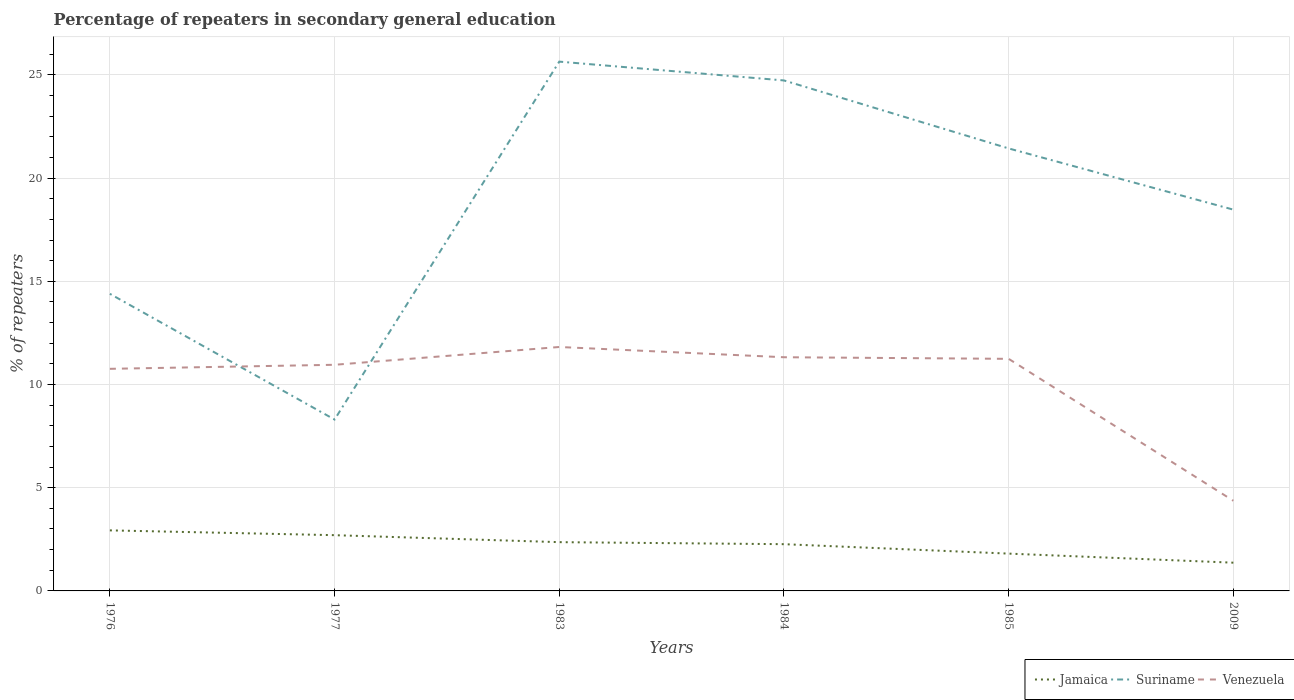How many different coloured lines are there?
Keep it short and to the point. 3. Does the line corresponding to Venezuela intersect with the line corresponding to Jamaica?
Offer a very short reply. No. Across all years, what is the maximum percentage of repeaters in secondary general education in Jamaica?
Offer a very short reply. 1.37. In which year was the percentage of repeaters in secondary general education in Jamaica maximum?
Your answer should be compact. 2009. What is the total percentage of repeaters in secondary general education in Jamaica in the graph?
Make the answer very short. 0.55. What is the difference between the highest and the second highest percentage of repeaters in secondary general education in Suriname?
Provide a succinct answer. 17.34. What is the difference between the highest and the lowest percentage of repeaters in secondary general education in Venezuela?
Your answer should be very brief. 5. How many lines are there?
Offer a very short reply. 3. How many years are there in the graph?
Your response must be concise. 6. Where does the legend appear in the graph?
Your response must be concise. Bottom right. How many legend labels are there?
Offer a terse response. 3. How are the legend labels stacked?
Your answer should be very brief. Horizontal. What is the title of the graph?
Your response must be concise. Percentage of repeaters in secondary general education. What is the label or title of the Y-axis?
Give a very brief answer. % of repeaters. What is the % of repeaters of Jamaica in 1976?
Provide a short and direct response. 2.93. What is the % of repeaters in Suriname in 1976?
Provide a short and direct response. 14.39. What is the % of repeaters in Venezuela in 1976?
Keep it short and to the point. 10.76. What is the % of repeaters in Jamaica in 1977?
Keep it short and to the point. 2.7. What is the % of repeaters in Suriname in 1977?
Provide a short and direct response. 8.3. What is the % of repeaters of Venezuela in 1977?
Keep it short and to the point. 10.96. What is the % of repeaters of Jamaica in 1983?
Give a very brief answer. 2.36. What is the % of repeaters in Suriname in 1983?
Offer a terse response. 25.64. What is the % of repeaters of Venezuela in 1983?
Your response must be concise. 11.82. What is the % of repeaters of Jamaica in 1984?
Make the answer very short. 2.26. What is the % of repeaters in Suriname in 1984?
Provide a short and direct response. 24.73. What is the % of repeaters of Venezuela in 1984?
Your response must be concise. 11.32. What is the % of repeaters in Jamaica in 1985?
Provide a short and direct response. 1.81. What is the % of repeaters in Suriname in 1985?
Your response must be concise. 21.44. What is the % of repeaters of Venezuela in 1985?
Keep it short and to the point. 11.24. What is the % of repeaters in Jamaica in 2009?
Ensure brevity in your answer.  1.37. What is the % of repeaters in Suriname in 2009?
Make the answer very short. 18.47. What is the % of repeaters in Venezuela in 2009?
Offer a very short reply. 4.37. Across all years, what is the maximum % of repeaters in Jamaica?
Keep it short and to the point. 2.93. Across all years, what is the maximum % of repeaters in Suriname?
Your answer should be compact. 25.64. Across all years, what is the maximum % of repeaters of Venezuela?
Offer a terse response. 11.82. Across all years, what is the minimum % of repeaters of Jamaica?
Keep it short and to the point. 1.37. Across all years, what is the minimum % of repeaters of Suriname?
Provide a succinct answer. 8.3. Across all years, what is the minimum % of repeaters in Venezuela?
Your answer should be very brief. 4.37. What is the total % of repeaters in Jamaica in the graph?
Offer a terse response. 13.44. What is the total % of repeaters of Suriname in the graph?
Ensure brevity in your answer.  112.98. What is the total % of repeaters of Venezuela in the graph?
Offer a very short reply. 60.47. What is the difference between the % of repeaters in Jamaica in 1976 and that in 1977?
Make the answer very short. 0.23. What is the difference between the % of repeaters of Suriname in 1976 and that in 1977?
Provide a succinct answer. 6.09. What is the difference between the % of repeaters of Venezuela in 1976 and that in 1977?
Provide a short and direct response. -0.2. What is the difference between the % of repeaters in Jamaica in 1976 and that in 1983?
Offer a terse response. 0.57. What is the difference between the % of repeaters of Suriname in 1976 and that in 1983?
Ensure brevity in your answer.  -11.25. What is the difference between the % of repeaters in Venezuela in 1976 and that in 1983?
Your answer should be very brief. -1.06. What is the difference between the % of repeaters in Jamaica in 1976 and that in 1984?
Keep it short and to the point. 0.67. What is the difference between the % of repeaters in Suriname in 1976 and that in 1984?
Your response must be concise. -10.34. What is the difference between the % of repeaters in Venezuela in 1976 and that in 1984?
Make the answer very short. -0.56. What is the difference between the % of repeaters in Jamaica in 1976 and that in 1985?
Keep it short and to the point. 1.13. What is the difference between the % of repeaters of Suriname in 1976 and that in 1985?
Offer a very short reply. -7.04. What is the difference between the % of repeaters of Venezuela in 1976 and that in 1985?
Make the answer very short. -0.48. What is the difference between the % of repeaters in Jamaica in 1976 and that in 2009?
Keep it short and to the point. 1.56. What is the difference between the % of repeaters in Suriname in 1976 and that in 2009?
Make the answer very short. -4.08. What is the difference between the % of repeaters of Venezuela in 1976 and that in 2009?
Your response must be concise. 6.39. What is the difference between the % of repeaters of Jamaica in 1977 and that in 1983?
Make the answer very short. 0.34. What is the difference between the % of repeaters of Suriname in 1977 and that in 1983?
Make the answer very short. -17.34. What is the difference between the % of repeaters in Venezuela in 1977 and that in 1983?
Your answer should be compact. -0.86. What is the difference between the % of repeaters in Jamaica in 1977 and that in 1984?
Give a very brief answer. 0.44. What is the difference between the % of repeaters in Suriname in 1977 and that in 1984?
Ensure brevity in your answer.  -16.43. What is the difference between the % of repeaters of Venezuela in 1977 and that in 1984?
Provide a succinct answer. -0.37. What is the difference between the % of repeaters of Jamaica in 1977 and that in 1985?
Offer a very short reply. 0.89. What is the difference between the % of repeaters in Suriname in 1977 and that in 1985?
Provide a short and direct response. -13.14. What is the difference between the % of repeaters of Venezuela in 1977 and that in 1985?
Offer a very short reply. -0.29. What is the difference between the % of repeaters of Jamaica in 1977 and that in 2009?
Your answer should be compact. 1.33. What is the difference between the % of repeaters in Suriname in 1977 and that in 2009?
Keep it short and to the point. -10.17. What is the difference between the % of repeaters in Venezuela in 1977 and that in 2009?
Make the answer very short. 6.59. What is the difference between the % of repeaters in Jamaica in 1983 and that in 1984?
Your response must be concise. 0.1. What is the difference between the % of repeaters in Suriname in 1983 and that in 1984?
Offer a very short reply. 0.91. What is the difference between the % of repeaters of Venezuela in 1983 and that in 1984?
Keep it short and to the point. 0.5. What is the difference between the % of repeaters in Jamaica in 1983 and that in 1985?
Your response must be concise. 0.55. What is the difference between the % of repeaters in Suriname in 1983 and that in 1985?
Ensure brevity in your answer.  4.21. What is the difference between the % of repeaters of Venezuela in 1983 and that in 1985?
Offer a very short reply. 0.57. What is the difference between the % of repeaters of Jamaica in 1983 and that in 2009?
Give a very brief answer. 0.99. What is the difference between the % of repeaters in Suriname in 1983 and that in 2009?
Make the answer very short. 7.17. What is the difference between the % of repeaters of Venezuela in 1983 and that in 2009?
Keep it short and to the point. 7.45. What is the difference between the % of repeaters in Jamaica in 1984 and that in 1985?
Offer a terse response. 0.46. What is the difference between the % of repeaters of Suriname in 1984 and that in 1985?
Your answer should be compact. 3.29. What is the difference between the % of repeaters of Venezuela in 1984 and that in 1985?
Keep it short and to the point. 0.08. What is the difference between the % of repeaters in Jamaica in 1984 and that in 2009?
Provide a short and direct response. 0.9. What is the difference between the % of repeaters in Suriname in 1984 and that in 2009?
Offer a very short reply. 6.26. What is the difference between the % of repeaters in Venezuela in 1984 and that in 2009?
Your answer should be compact. 6.95. What is the difference between the % of repeaters of Jamaica in 1985 and that in 2009?
Your answer should be very brief. 0.44. What is the difference between the % of repeaters in Suriname in 1985 and that in 2009?
Offer a very short reply. 2.97. What is the difference between the % of repeaters of Venezuela in 1985 and that in 2009?
Your response must be concise. 6.88. What is the difference between the % of repeaters of Jamaica in 1976 and the % of repeaters of Suriname in 1977?
Your response must be concise. -5.37. What is the difference between the % of repeaters in Jamaica in 1976 and the % of repeaters in Venezuela in 1977?
Offer a terse response. -8.02. What is the difference between the % of repeaters of Suriname in 1976 and the % of repeaters of Venezuela in 1977?
Your answer should be very brief. 3.44. What is the difference between the % of repeaters of Jamaica in 1976 and the % of repeaters of Suriname in 1983?
Keep it short and to the point. -22.71. What is the difference between the % of repeaters in Jamaica in 1976 and the % of repeaters in Venezuela in 1983?
Your answer should be compact. -8.88. What is the difference between the % of repeaters in Suriname in 1976 and the % of repeaters in Venezuela in 1983?
Your answer should be compact. 2.58. What is the difference between the % of repeaters of Jamaica in 1976 and the % of repeaters of Suriname in 1984?
Give a very brief answer. -21.8. What is the difference between the % of repeaters in Jamaica in 1976 and the % of repeaters in Venezuela in 1984?
Make the answer very short. -8.39. What is the difference between the % of repeaters in Suriname in 1976 and the % of repeaters in Venezuela in 1984?
Offer a very short reply. 3.07. What is the difference between the % of repeaters in Jamaica in 1976 and the % of repeaters in Suriname in 1985?
Your response must be concise. -18.5. What is the difference between the % of repeaters in Jamaica in 1976 and the % of repeaters in Venezuela in 1985?
Give a very brief answer. -8.31. What is the difference between the % of repeaters of Suriname in 1976 and the % of repeaters of Venezuela in 1985?
Offer a very short reply. 3.15. What is the difference between the % of repeaters of Jamaica in 1976 and the % of repeaters of Suriname in 2009?
Offer a terse response. -15.54. What is the difference between the % of repeaters of Jamaica in 1976 and the % of repeaters of Venezuela in 2009?
Your answer should be very brief. -1.44. What is the difference between the % of repeaters of Suriname in 1976 and the % of repeaters of Venezuela in 2009?
Provide a short and direct response. 10.03. What is the difference between the % of repeaters in Jamaica in 1977 and the % of repeaters in Suriname in 1983?
Provide a succinct answer. -22.94. What is the difference between the % of repeaters in Jamaica in 1977 and the % of repeaters in Venezuela in 1983?
Offer a terse response. -9.12. What is the difference between the % of repeaters in Suriname in 1977 and the % of repeaters in Venezuela in 1983?
Keep it short and to the point. -3.52. What is the difference between the % of repeaters in Jamaica in 1977 and the % of repeaters in Suriname in 1984?
Offer a very short reply. -22.03. What is the difference between the % of repeaters in Jamaica in 1977 and the % of repeaters in Venezuela in 1984?
Give a very brief answer. -8.62. What is the difference between the % of repeaters of Suriname in 1977 and the % of repeaters of Venezuela in 1984?
Provide a succinct answer. -3.02. What is the difference between the % of repeaters of Jamaica in 1977 and the % of repeaters of Suriname in 1985?
Give a very brief answer. -18.74. What is the difference between the % of repeaters of Jamaica in 1977 and the % of repeaters of Venezuela in 1985?
Offer a terse response. -8.54. What is the difference between the % of repeaters in Suriname in 1977 and the % of repeaters in Venezuela in 1985?
Offer a very short reply. -2.94. What is the difference between the % of repeaters in Jamaica in 1977 and the % of repeaters in Suriname in 2009?
Your answer should be very brief. -15.77. What is the difference between the % of repeaters in Jamaica in 1977 and the % of repeaters in Venezuela in 2009?
Your answer should be very brief. -1.67. What is the difference between the % of repeaters in Suriname in 1977 and the % of repeaters in Venezuela in 2009?
Your response must be concise. 3.93. What is the difference between the % of repeaters of Jamaica in 1983 and the % of repeaters of Suriname in 1984?
Your response must be concise. -22.37. What is the difference between the % of repeaters in Jamaica in 1983 and the % of repeaters in Venezuela in 1984?
Your answer should be compact. -8.96. What is the difference between the % of repeaters in Suriname in 1983 and the % of repeaters in Venezuela in 1984?
Make the answer very short. 14.32. What is the difference between the % of repeaters in Jamaica in 1983 and the % of repeaters in Suriname in 1985?
Offer a very short reply. -19.08. What is the difference between the % of repeaters in Jamaica in 1983 and the % of repeaters in Venezuela in 1985?
Provide a short and direct response. -8.88. What is the difference between the % of repeaters in Suriname in 1983 and the % of repeaters in Venezuela in 1985?
Offer a terse response. 14.4. What is the difference between the % of repeaters in Jamaica in 1983 and the % of repeaters in Suriname in 2009?
Ensure brevity in your answer.  -16.11. What is the difference between the % of repeaters in Jamaica in 1983 and the % of repeaters in Venezuela in 2009?
Offer a terse response. -2.01. What is the difference between the % of repeaters in Suriname in 1983 and the % of repeaters in Venezuela in 2009?
Provide a succinct answer. 21.27. What is the difference between the % of repeaters of Jamaica in 1984 and the % of repeaters of Suriname in 1985?
Your answer should be compact. -19.17. What is the difference between the % of repeaters of Jamaica in 1984 and the % of repeaters of Venezuela in 1985?
Provide a short and direct response. -8.98. What is the difference between the % of repeaters of Suriname in 1984 and the % of repeaters of Venezuela in 1985?
Provide a succinct answer. 13.49. What is the difference between the % of repeaters in Jamaica in 1984 and the % of repeaters in Suriname in 2009?
Give a very brief answer. -16.21. What is the difference between the % of repeaters of Jamaica in 1984 and the % of repeaters of Venezuela in 2009?
Keep it short and to the point. -2.1. What is the difference between the % of repeaters of Suriname in 1984 and the % of repeaters of Venezuela in 2009?
Your answer should be very brief. 20.36. What is the difference between the % of repeaters of Jamaica in 1985 and the % of repeaters of Suriname in 2009?
Ensure brevity in your answer.  -16.66. What is the difference between the % of repeaters in Jamaica in 1985 and the % of repeaters in Venezuela in 2009?
Provide a succinct answer. -2.56. What is the difference between the % of repeaters in Suriname in 1985 and the % of repeaters in Venezuela in 2009?
Your answer should be very brief. 17.07. What is the average % of repeaters of Jamaica per year?
Give a very brief answer. 2.24. What is the average % of repeaters in Suriname per year?
Offer a terse response. 18.83. What is the average % of repeaters of Venezuela per year?
Your answer should be very brief. 10.08. In the year 1976, what is the difference between the % of repeaters in Jamaica and % of repeaters in Suriname?
Your response must be concise. -11.46. In the year 1976, what is the difference between the % of repeaters in Jamaica and % of repeaters in Venezuela?
Offer a terse response. -7.83. In the year 1976, what is the difference between the % of repeaters of Suriname and % of repeaters of Venezuela?
Give a very brief answer. 3.63. In the year 1977, what is the difference between the % of repeaters of Jamaica and % of repeaters of Suriname?
Give a very brief answer. -5.6. In the year 1977, what is the difference between the % of repeaters of Jamaica and % of repeaters of Venezuela?
Offer a very short reply. -8.26. In the year 1977, what is the difference between the % of repeaters of Suriname and % of repeaters of Venezuela?
Your response must be concise. -2.65. In the year 1983, what is the difference between the % of repeaters in Jamaica and % of repeaters in Suriname?
Your answer should be very brief. -23.28. In the year 1983, what is the difference between the % of repeaters in Jamaica and % of repeaters in Venezuela?
Provide a short and direct response. -9.46. In the year 1983, what is the difference between the % of repeaters of Suriname and % of repeaters of Venezuela?
Your response must be concise. 13.83. In the year 1984, what is the difference between the % of repeaters of Jamaica and % of repeaters of Suriname?
Offer a very short reply. -22.47. In the year 1984, what is the difference between the % of repeaters in Jamaica and % of repeaters in Venezuela?
Your answer should be compact. -9.06. In the year 1984, what is the difference between the % of repeaters in Suriname and % of repeaters in Venezuela?
Ensure brevity in your answer.  13.41. In the year 1985, what is the difference between the % of repeaters of Jamaica and % of repeaters of Suriname?
Provide a succinct answer. -19.63. In the year 1985, what is the difference between the % of repeaters of Jamaica and % of repeaters of Venezuela?
Ensure brevity in your answer.  -9.44. In the year 1985, what is the difference between the % of repeaters of Suriname and % of repeaters of Venezuela?
Offer a very short reply. 10.19. In the year 2009, what is the difference between the % of repeaters in Jamaica and % of repeaters in Suriname?
Make the answer very short. -17.1. In the year 2009, what is the difference between the % of repeaters of Jamaica and % of repeaters of Venezuela?
Your response must be concise. -3. In the year 2009, what is the difference between the % of repeaters of Suriname and % of repeaters of Venezuela?
Your response must be concise. 14.1. What is the ratio of the % of repeaters of Jamaica in 1976 to that in 1977?
Your answer should be very brief. 1.09. What is the ratio of the % of repeaters in Suriname in 1976 to that in 1977?
Your answer should be compact. 1.73. What is the ratio of the % of repeaters of Venezuela in 1976 to that in 1977?
Make the answer very short. 0.98. What is the ratio of the % of repeaters of Jamaica in 1976 to that in 1983?
Your answer should be compact. 1.24. What is the ratio of the % of repeaters of Suriname in 1976 to that in 1983?
Give a very brief answer. 0.56. What is the ratio of the % of repeaters in Venezuela in 1976 to that in 1983?
Your response must be concise. 0.91. What is the ratio of the % of repeaters in Jamaica in 1976 to that in 1984?
Ensure brevity in your answer.  1.3. What is the ratio of the % of repeaters in Suriname in 1976 to that in 1984?
Your answer should be very brief. 0.58. What is the ratio of the % of repeaters in Venezuela in 1976 to that in 1984?
Offer a very short reply. 0.95. What is the ratio of the % of repeaters of Jamaica in 1976 to that in 1985?
Provide a short and direct response. 1.62. What is the ratio of the % of repeaters of Suriname in 1976 to that in 1985?
Offer a very short reply. 0.67. What is the ratio of the % of repeaters in Venezuela in 1976 to that in 1985?
Your answer should be very brief. 0.96. What is the ratio of the % of repeaters in Jamaica in 1976 to that in 2009?
Keep it short and to the point. 2.14. What is the ratio of the % of repeaters of Suriname in 1976 to that in 2009?
Give a very brief answer. 0.78. What is the ratio of the % of repeaters of Venezuela in 1976 to that in 2009?
Ensure brevity in your answer.  2.46. What is the ratio of the % of repeaters of Jamaica in 1977 to that in 1983?
Offer a terse response. 1.14. What is the ratio of the % of repeaters in Suriname in 1977 to that in 1983?
Make the answer very short. 0.32. What is the ratio of the % of repeaters of Venezuela in 1977 to that in 1983?
Offer a very short reply. 0.93. What is the ratio of the % of repeaters of Jamaica in 1977 to that in 1984?
Your answer should be compact. 1.19. What is the ratio of the % of repeaters in Suriname in 1977 to that in 1984?
Offer a terse response. 0.34. What is the ratio of the % of repeaters of Venezuela in 1977 to that in 1984?
Make the answer very short. 0.97. What is the ratio of the % of repeaters of Jamaica in 1977 to that in 1985?
Your answer should be compact. 1.49. What is the ratio of the % of repeaters in Suriname in 1977 to that in 1985?
Your response must be concise. 0.39. What is the ratio of the % of repeaters of Venezuela in 1977 to that in 1985?
Your answer should be very brief. 0.97. What is the ratio of the % of repeaters in Jamaica in 1977 to that in 2009?
Ensure brevity in your answer.  1.97. What is the ratio of the % of repeaters of Suriname in 1977 to that in 2009?
Keep it short and to the point. 0.45. What is the ratio of the % of repeaters in Venezuela in 1977 to that in 2009?
Offer a very short reply. 2.51. What is the ratio of the % of repeaters in Jamaica in 1983 to that in 1984?
Provide a succinct answer. 1.04. What is the ratio of the % of repeaters in Suriname in 1983 to that in 1984?
Offer a very short reply. 1.04. What is the ratio of the % of repeaters in Venezuela in 1983 to that in 1984?
Your answer should be compact. 1.04. What is the ratio of the % of repeaters in Jamaica in 1983 to that in 1985?
Keep it short and to the point. 1.31. What is the ratio of the % of repeaters in Suriname in 1983 to that in 1985?
Make the answer very short. 1.2. What is the ratio of the % of repeaters of Venezuela in 1983 to that in 1985?
Offer a very short reply. 1.05. What is the ratio of the % of repeaters in Jamaica in 1983 to that in 2009?
Give a very brief answer. 1.73. What is the ratio of the % of repeaters of Suriname in 1983 to that in 2009?
Provide a short and direct response. 1.39. What is the ratio of the % of repeaters in Venezuela in 1983 to that in 2009?
Offer a very short reply. 2.71. What is the ratio of the % of repeaters in Jamaica in 1984 to that in 1985?
Provide a short and direct response. 1.25. What is the ratio of the % of repeaters of Suriname in 1984 to that in 1985?
Your answer should be compact. 1.15. What is the ratio of the % of repeaters of Jamaica in 1984 to that in 2009?
Your answer should be very brief. 1.66. What is the ratio of the % of repeaters of Suriname in 1984 to that in 2009?
Make the answer very short. 1.34. What is the ratio of the % of repeaters of Venezuela in 1984 to that in 2009?
Your answer should be compact. 2.59. What is the ratio of the % of repeaters of Jamaica in 1985 to that in 2009?
Your answer should be compact. 1.32. What is the ratio of the % of repeaters in Suriname in 1985 to that in 2009?
Your response must be concise. 1.16. What is the ratio of the % of repeaters in Venezuela in 1985 to that in 2009?
Your answer should be compact. 2.57. What is the difference between the highest and the second highest % of repeaters in Jamaica?
Your response must be concise. 0.23. What is the difference between the highest and the second highest % of repeaters in Suriname?
Provide a succinct answer. 0.91. What is the difference between the highest and the second highest % of repeaters of Venezuela?
Offer a terse response. 0.5. What is the difference between the highest and the lowest % of repeaters in Jamaica?
Your answer should be very brief. 1.56. What is the difference between the highest and the lowest % of repeaters in Suriname?
Your response must be concise. 17.34. What is the difference between the highest and the lowest % of repeaters of Venezuela?
Your answer should be very brief. 7.45. 